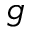Convert formula to latex. <formula><loc_0><loc_0><loc_500><loc_500>g</formula> 